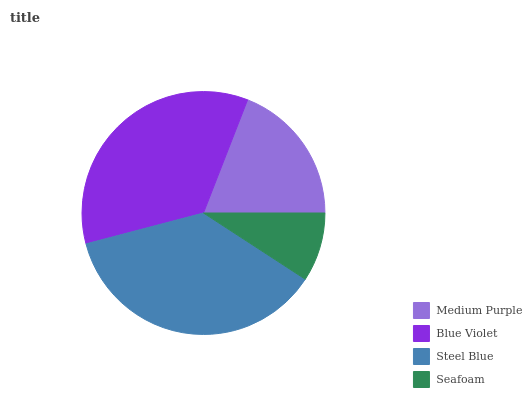Is Seafoam the minimum?
Answer yes or no. Yes. Is Steel Blue the maximum?
Answer yes or no. Yes. Is Blue Violet the minimum?
Answer yes or no. No. Is Blue Violet the maximum?
Answer yes or no. No. Is Blue Violet greater than Medium Purple?
Answer yes or no. Yes. Is Medium Purple less than Blue Violet?
Answer yes or no. Yes. Is Medium Purple greater than Blue Violet?
Answer yes or no. No. Is Blue Violet less than Medium Purple?
Answer yes or no. No. Is Blue Violet the high median?
Answer yes or no. Yes. Is Medium Purple the low median?
Answer yes or no. Yes. Is Steel Blue the high median?
Answer yes or no. No. Is Seafoam the low median?
Answer yes or no. No. 